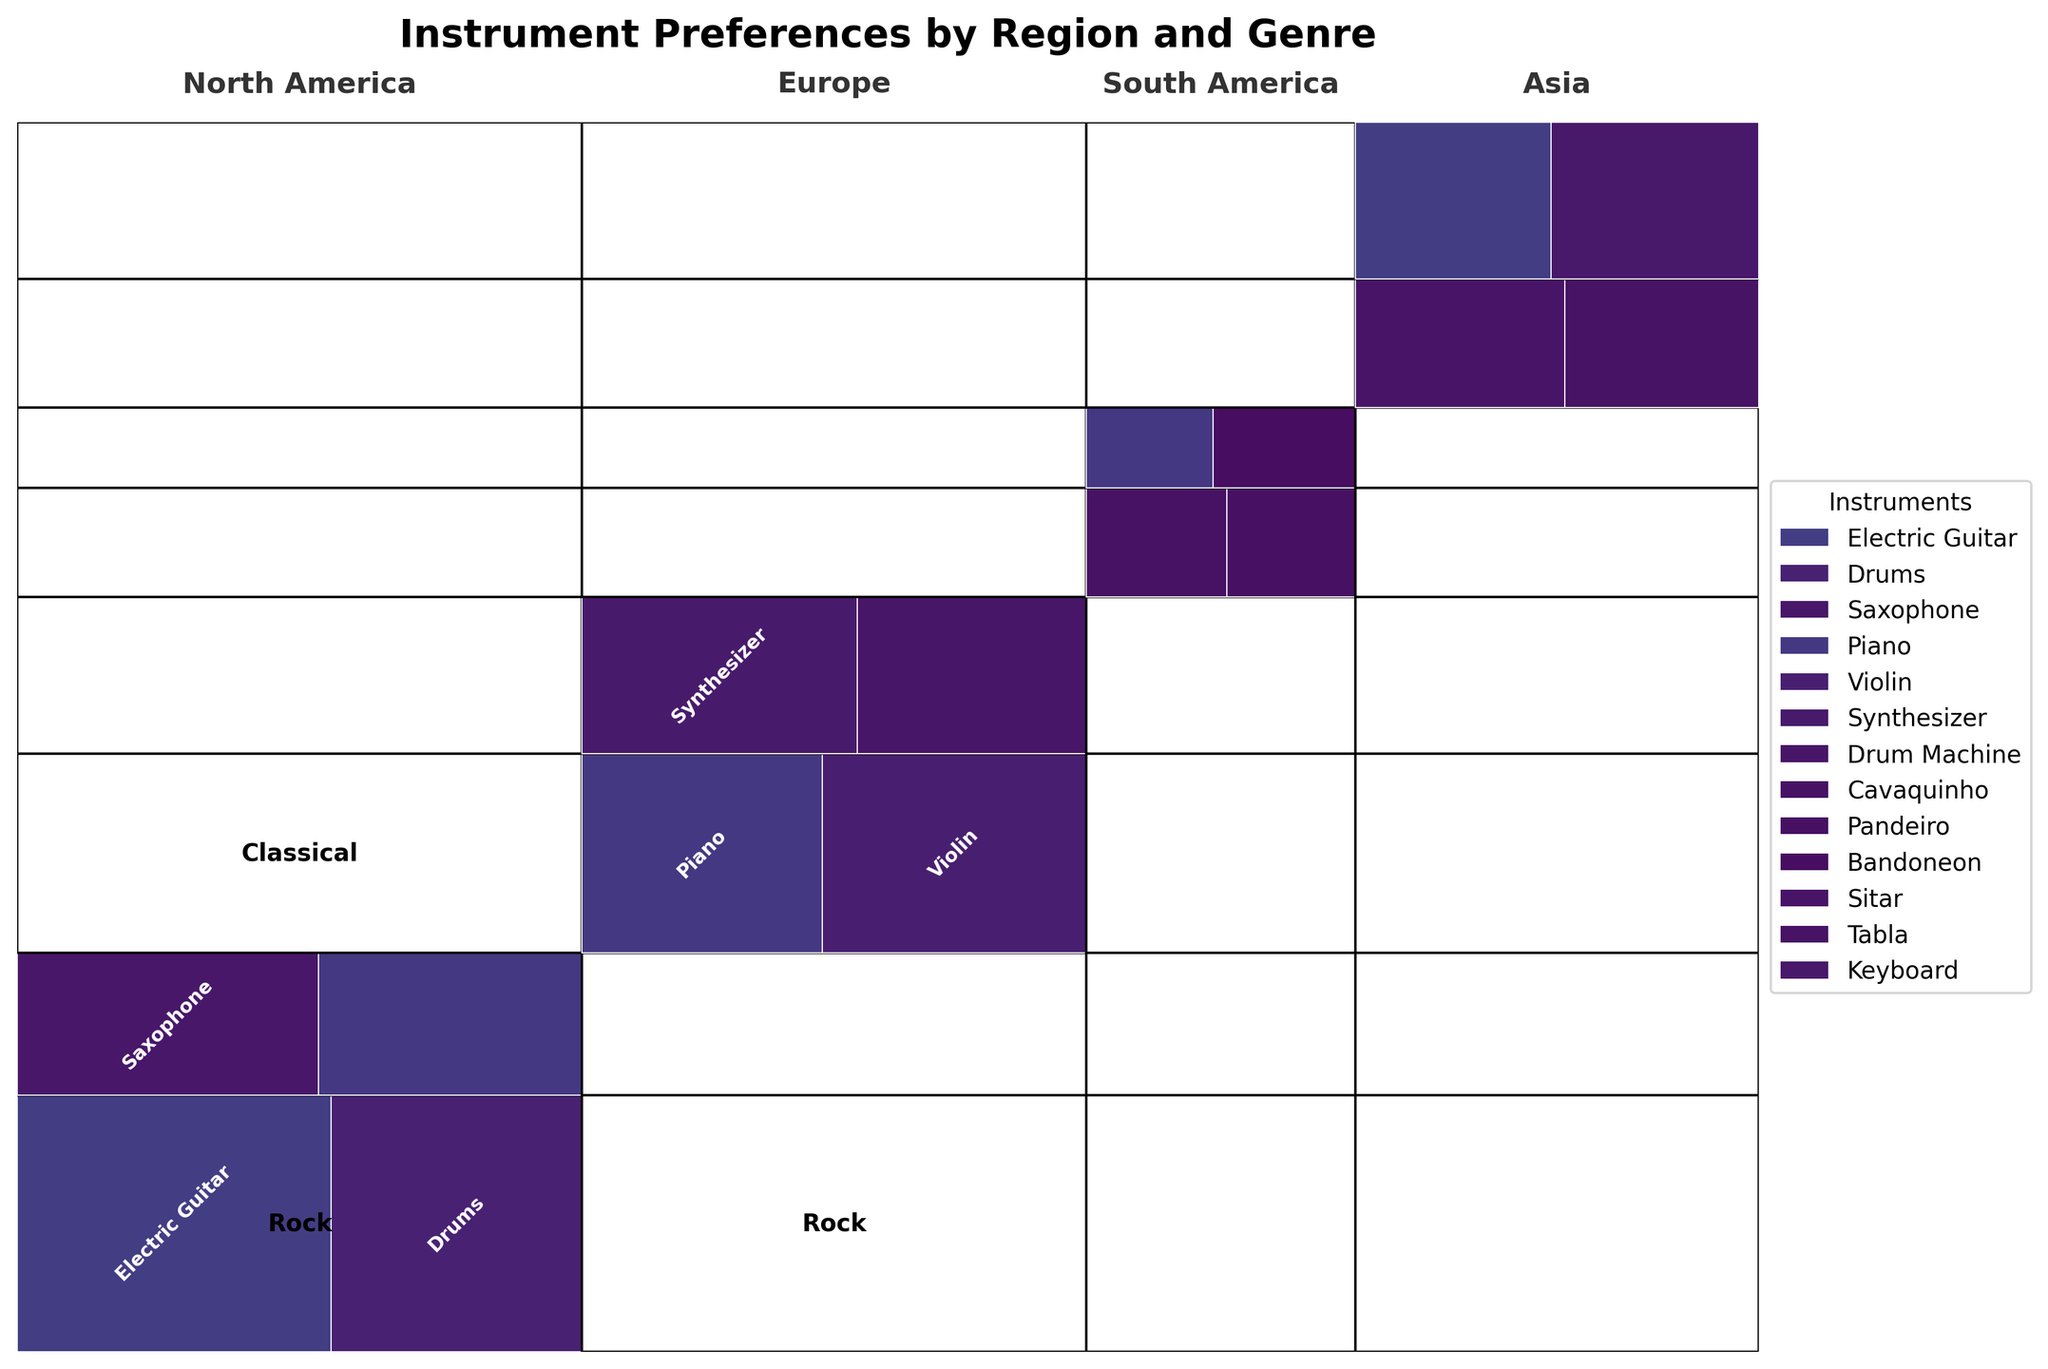Which region has the highest preference for the Electric Guitar in Rock music? To identify the region with the highest preference, look for the largest rectangle colored for the Electric Guitar within the Rock genre. North America's section for Rock includes a larger Electric Guitar component compared to other regions.
Answer: North America What is the total count of musicians in Classical genre across Europe? This involves summing the counts for different instruments in the Classical genre within the Europe region. The given counts are Violin (110) and Piano (100). Summing these gives 110 + 100 = 210.
Answer: 210 Compare the preference for Piano in Jazz genre between North America and Europe. There is no data for Europe in the Jazz genre. In North America, the Piano count is 70. Since Europe does not have any representation for Jazz, North America has a higher preference for Piano in this genre.
Answer: North America Do musicians in Asia prefer traditional instruments more than modern ones in K-pop? Compare the size of rectangles labeled as Traditional instruments (Sitar and Tabla) vs. modern instruments in K-pop (Keyboard and Electric Guitar). The areas for K-pop’s modern instruments (Keyboard, Electric Guitar) are relatively larger than those for traditional instruments in Asia.
Answer: No How does the popularity of the Drums in Rock compare across all regions? Look for the use of Drums in Rock across all regions. Only North America has a significant preference for Drums in Rock, shown by a prominent rectangle. This suggests Drums in Rock are only popular in North America among these regions.
Answer: North America only Which genre appears to dominate within Europe in terms of instrument diversity? Evaluate the number of different instruments represented within genres in Europe. The Classical genre has diverse instruments (Violin, Piano), but Electronic also has a varied set (Synthesizer, Drum Machine). Both genres are equally diverse, having different instrument representations.
Answer: Classical and Electronic Is the overall preference for Piano more in Classical or Jazz across all regions? Sum the counts for Piano in Classical across Europe (100) and in Jazz across North America (70). Classical genre has a count of 100, whereas Jazz has a count of 70. Thus, the overall preference for Piano is higher in Classical.
Answer: Classical In South America, is the preference for Piano more in Samba or Tango? Compare the sizes of the rectangles representing Piano in Samba and Tango within South America. The count for Piano in Samba is not given, but in Tango, it's 40. Therefore, preference for Piano is in Tango.
Answer: Tango 